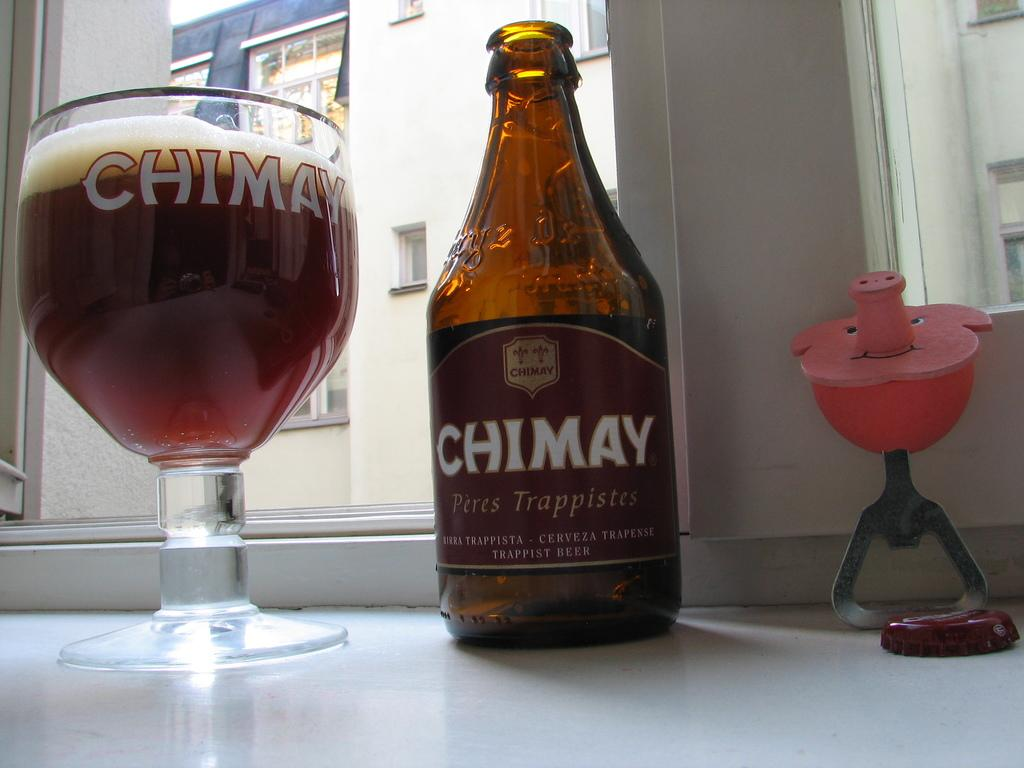<image>
Give a short and clear explanation of the subsequent image. A bottle and a glass both have the brand name Chimay on them. 